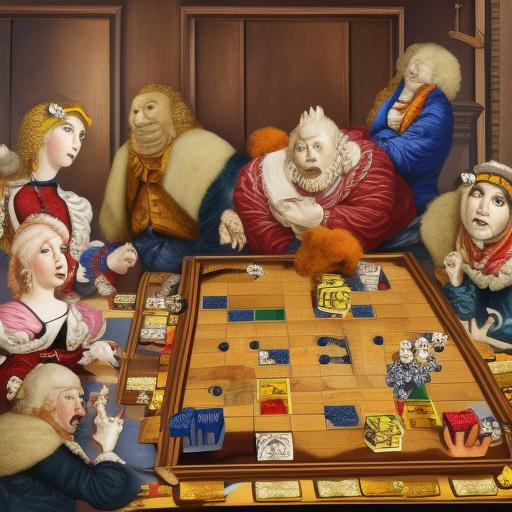Are people playing chess in the painting?
 Yes 